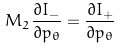Convert formula to latex. <formula><loc_0><loc_0><loc_500><loc_500>M _ { 2 } \frac { \partial I _ { - } } { \partial p _ { \theta } } = \frac { \partial I _ { + } } { \partial p _ { \theta } }</formula> 